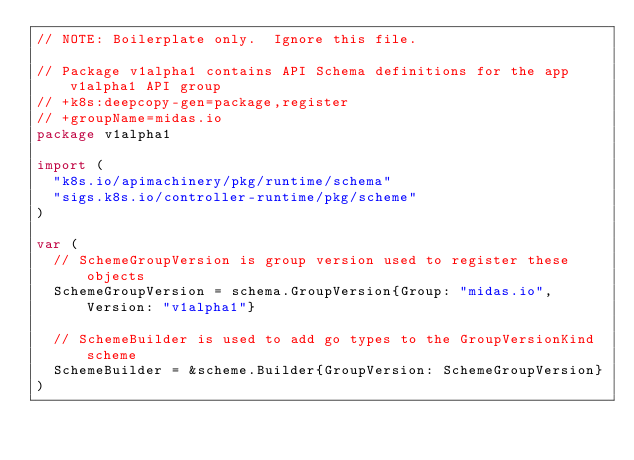Convert code to text. <code><loc_0><loc_0><loc_500><loc_500><_Go_>// NOTE: Boilerplate only.  Ignore this file.

// Package v1alpha1 contains API Schema definitions for the app v1alpha1 API group
// +k8s:deepcopy-gen=package,register
// +groupName=midas.io
package v1alpha1

import (
	"k8s.io/apimachinery/pkg/runtime/schema"
	"sigs.k8s.io/controller-runtime/pkg/scheme"
)

var (
	// SchemeGroupVersion is group version used to register these objects
	SchemeGroupVersion = schema.GroupVersion{Group: "midas.io", Version: "v1alpha1"}

	// SchemeBuilder is used to add go types to the GroupVersionKind scheme
	SchemeBuilder = &scheme.Builder{GroupVersion: SchemeGroupVersion}
)
</code> 